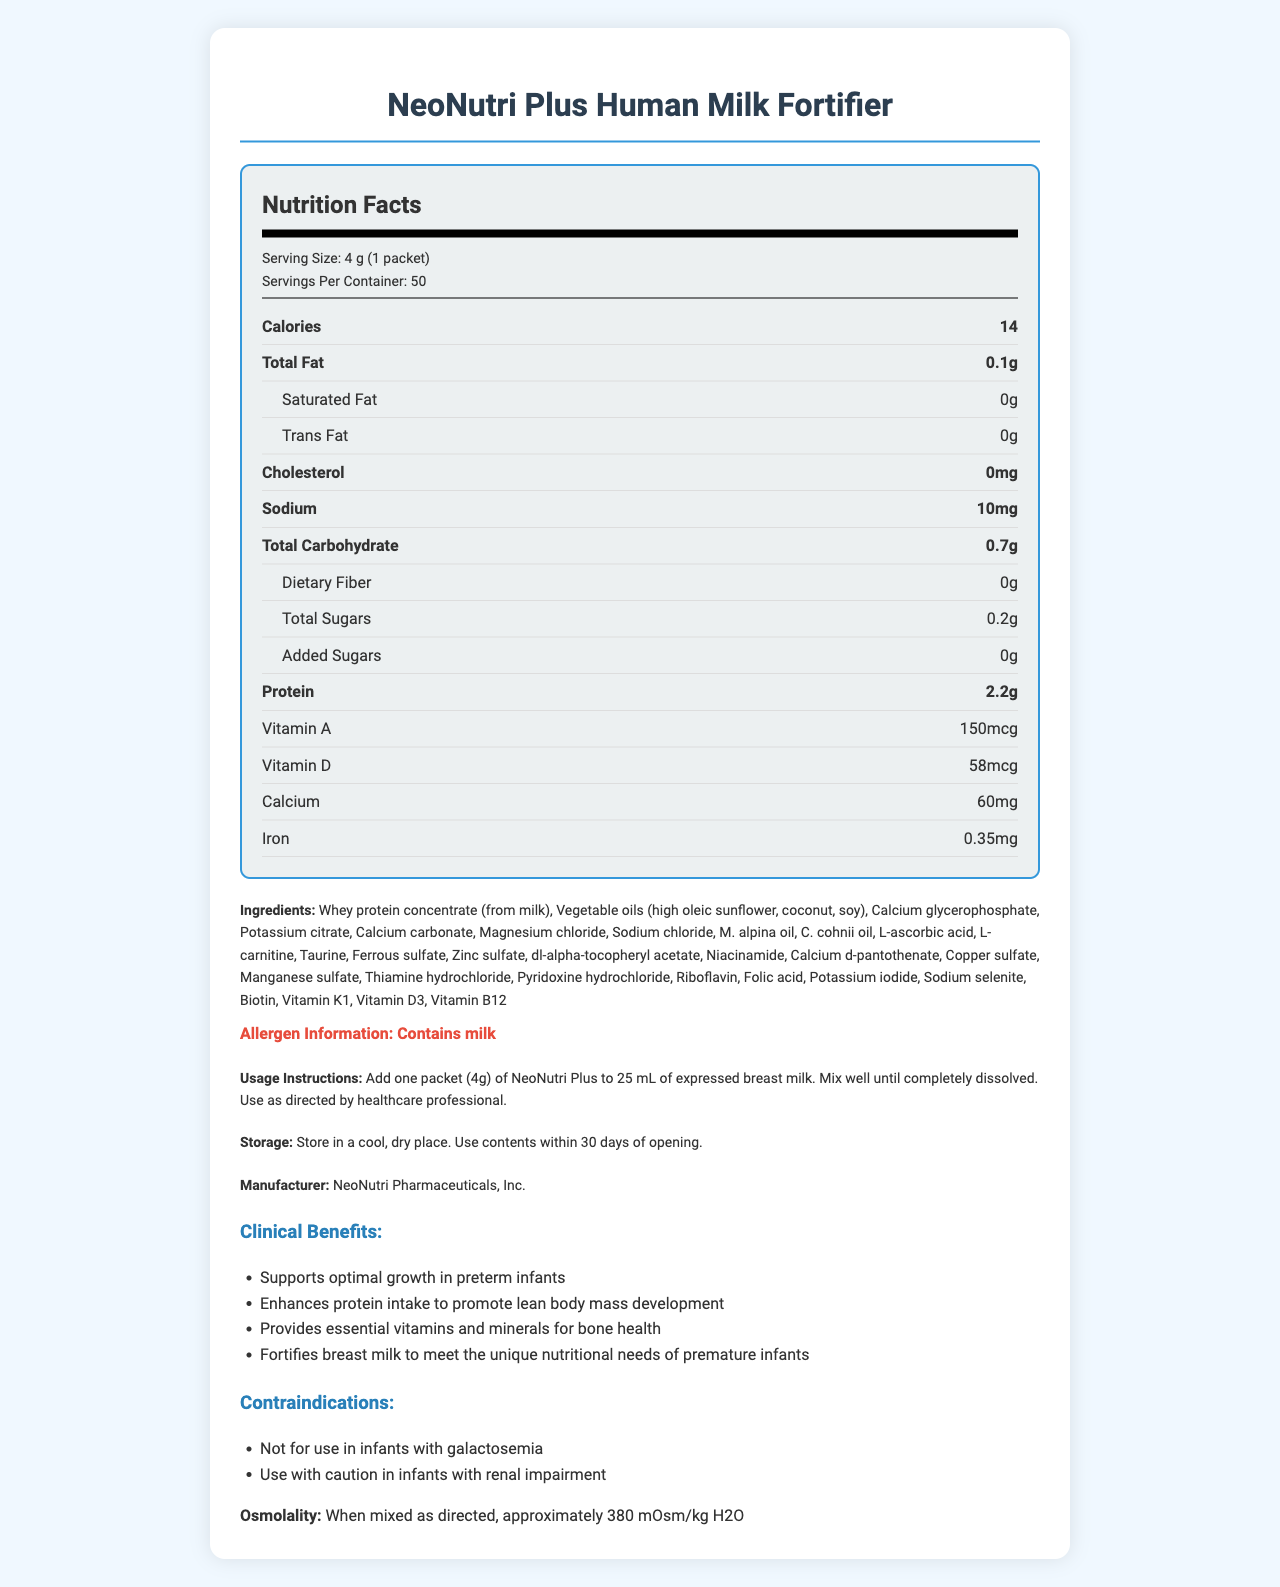what is the serving size? The serving size is specified as "4 g (1 packet)" in the document under the serving information.
Answer: 4 g (1 packet) what is the calorie content per serving? The document lists the calorie content per serving as 14 under the nutrient rows.
Answer: 14 how much protein does one serving contain? The amount of protein per serving is stated as 2.2 g in the document.
Answer: 2.2 g which allergens are present in this product? The allergen information section lists "Contains milk" as the allergen present in the product.
Answer: Contains milk how should the NeoNutri Plus be stored? The storage instructions specify to store the product in a cool, dry place and use the contents within 30 days of opening.
Answer: Store in a cool, dry place. Use contents within 30 days of opening. how many servings are there in one container? A. 25 B. 30 C. 50 D. 75 The number of servings per container is mentioned as 50 in the serving information section.
Answer: C. 50 what is the total fat content per serving? A. 0 g B. 0.1 g C. 0.2 g D. 0.3 g The total fat content per serving is specified as 0.1 g in the document under nutrient rows.
Answer: B. 0.1 g does the product contain any dietary fiber? The document states that the dietary fiber content is 0, which means there is no dietary fiber in the product.
Answer: No is the product suitable for infants with galactosemia? The contraindications section notes that the product is not for use in infants with galactosemia.
Answer: No can the exact number of calories from fats be determined from the document? The document provides the total calories and the total fat content but does not specifically list the calories derived from fats.
Answer: Cannot be determined summarize the main idea of this document. The document provides comprehensive details about NeoNutri Plus Human Milk Fortifier, including its nutritional content, ingredient list, preparation instructions, storage instructions, clinical benefits, contraindications, and its usage for supporting premature infants' health.
Answer: The document describes the nutritional information, ingredient list, usage instructions, storage guidelines, clinical benefits, and contraindications of NeoNutri Plus Human Milk Fortifier. It specifies that one packet (4 g) should be added to 25 mL of expressed breast milk and details the essential vitamins and minerals included to support the growth and health of premature infants. 